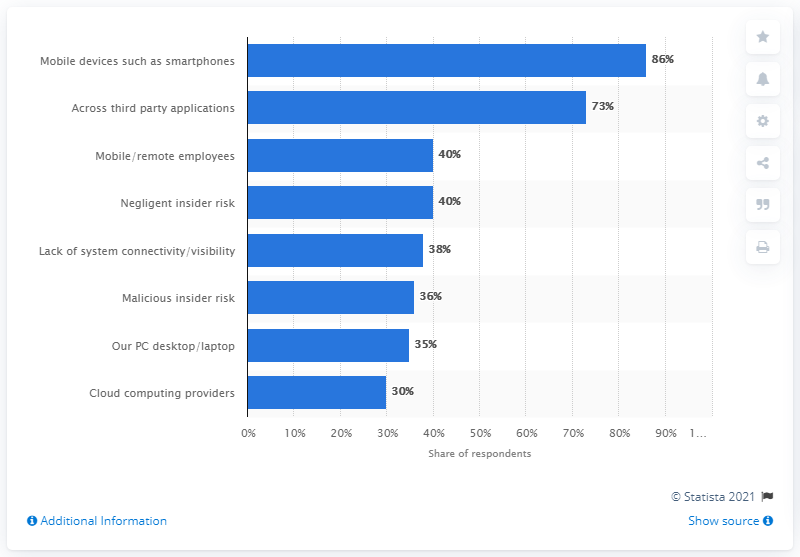Outline some significant characteristics in this image. According to the results of the survey, 86% of respondents believed that mobile devices posed the biggest threat to endpoint security. 